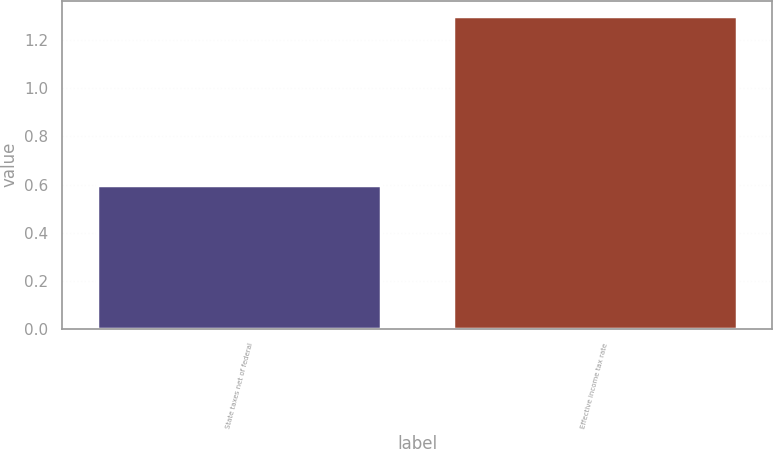Convert chart. <chart><loc_0><loc_0><loc_500><loc_500><bar_chart><fcel>State taxes net of federal<fcel>Effective income tax rate<nl><fcel>0.6<fcel>1.3<nl></chart> 